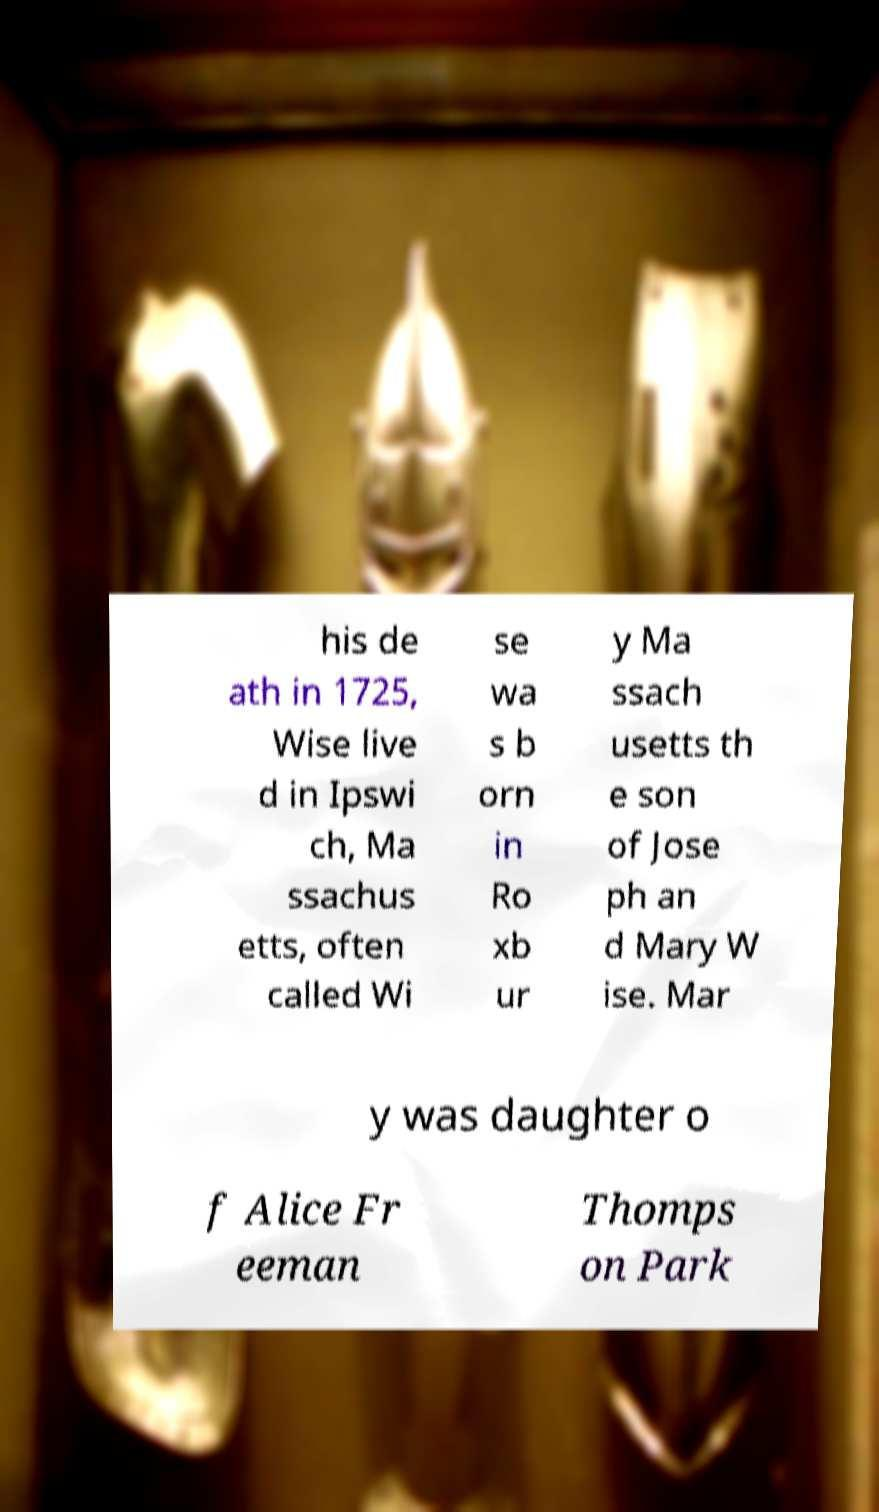For documentation purposes, I need the text within this image transcribed. Could you provide that? his de ath in 1725, Wise live d in Ipswi ch, Ma ssachus etts, often called Wi se wa s b orn in Ro xb ur y Ma ssach usetts th e son of Jose ph an d Mary W ise. Mar y was daughter o f Alice Fr eeman Thomps on Park 